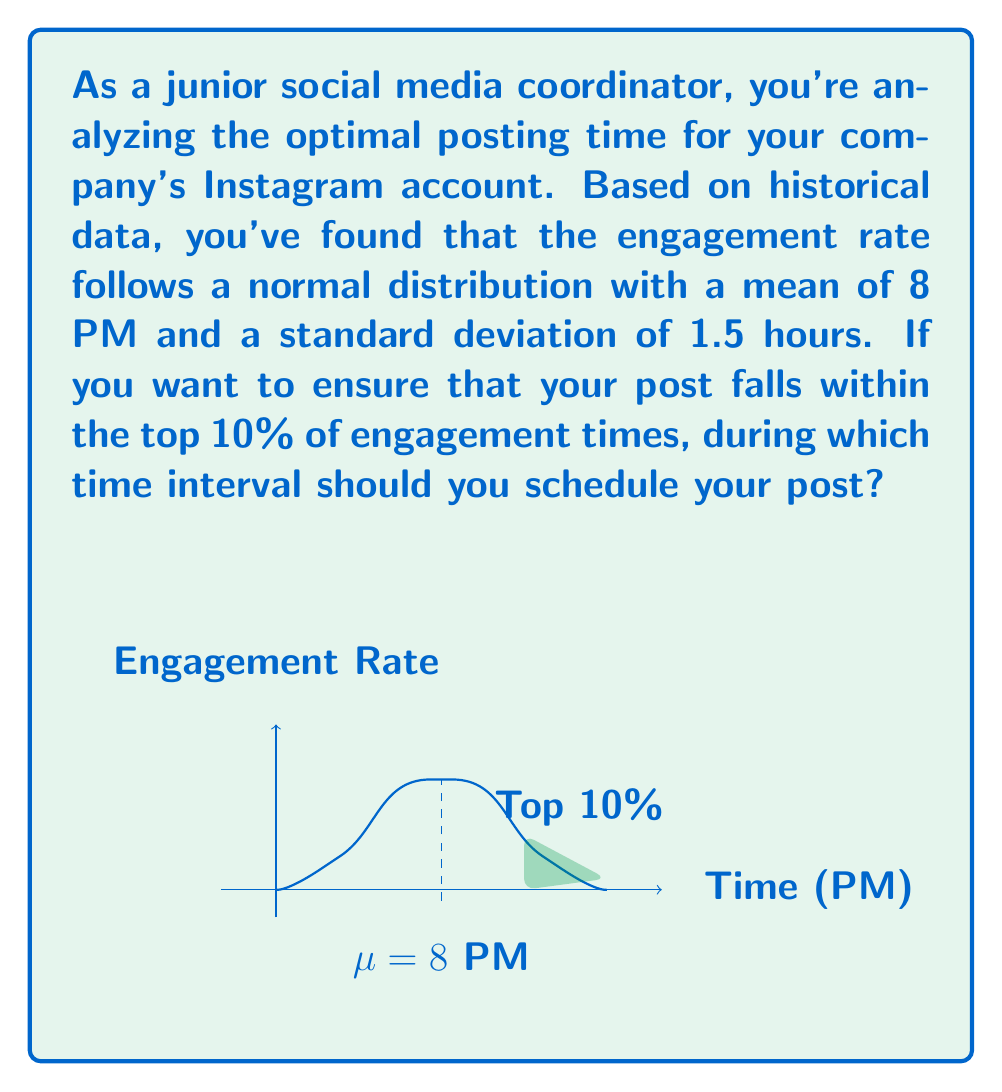Teach me how to tackle this problem. Let's approach this step-by-step:

1) We're dealing with a normal distribution where:
   $\mu = 8$ PM (mean)
   $\sigma = 1.5$ hours (standard deviation)

2) We want to find the time that marks the beginning of the top 10% of engagement times. This corresponds to the 90th percentile of the distribution.

3) For a normal distribution, we can use the z-score formula:
   $z = \frac{x - \mu}{\sigma}$

   where $z$ is the number of standard deviations from the mean, $x$ is the value we're looking for, $\mu$ is the mean, and $\sigma$ is the standard deviation.

4) The z-score for the 90th percentile is approximately 1.28 (this is a standard value from z-score tables).

5) Now we can solve for $x$:
   $1.28 = \frac{x - 8}{1.5}$

6) Multiply both sides by 1.5:
   $1.92 = x - 8$

7) Add 8 to both sides:
   $x = 9.92$

8) This means the 90th percentile is at approximately 9:55 PM.

9) Therefore, to be in the top 10% of engagement times, you should post anytime after 9:55 PM.

10) For a complete interval, we can say from 9:55 PM until the latest possible time (which would be midnight in a practical sense, or theoretically positive infinity in terms of the normal distribution).
Answer: 9:55 PM to 12:00 AM 